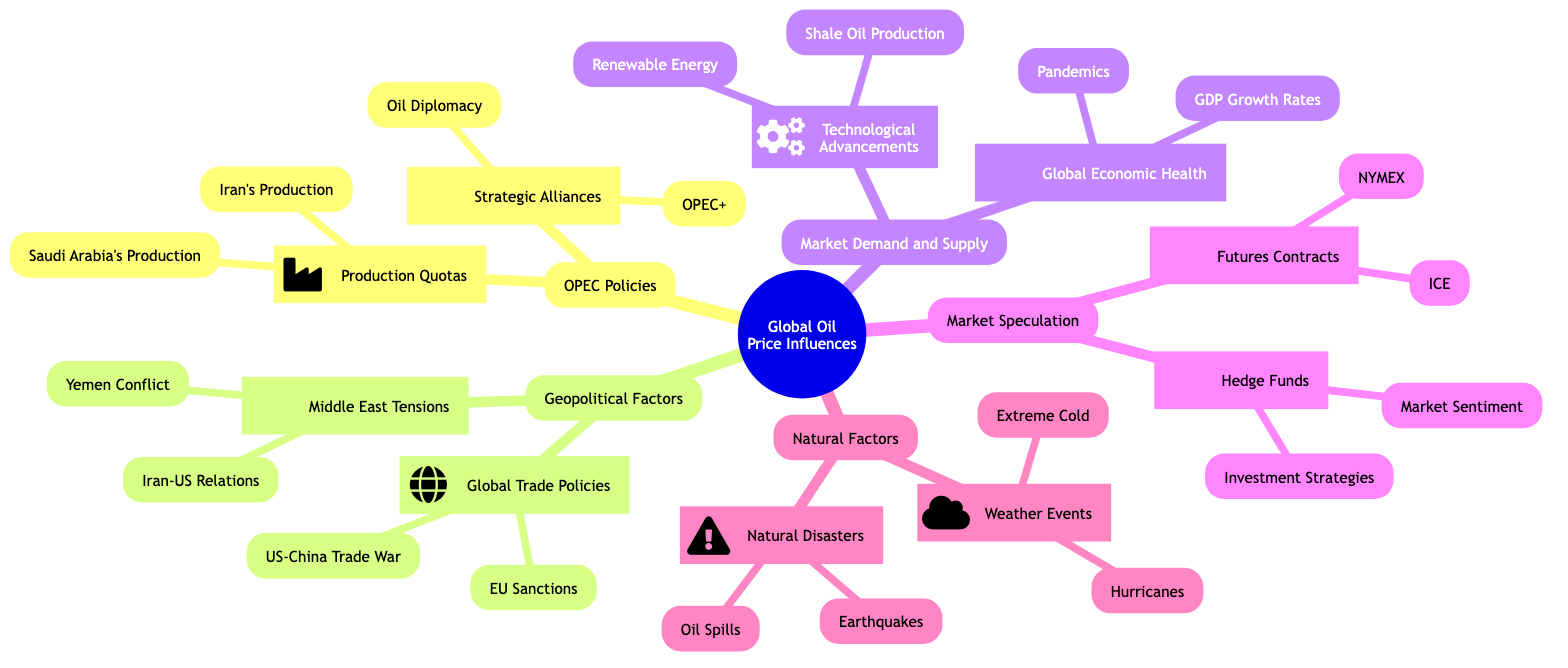What are the two main sections under OPEC Policies? The diagram shows two main sections under OPEC Policies: Production Quotas and Strategic Alliances.
Answer: Production Quotas, Strategic Alliances How many factors are listed under Geopolitical Factors? Under Geopolitical Factors, there are two factors: Middle East Tensions and Global Trade Policies, totaling two sections.
Answer: 2 Which country is specifically mentioned as having an influence on production adjustments? The diagram mentions Saudi Arabia's Production as having a leading role in production adjustments.
Answer: Saudi Arabia What is one impact of US-China Trade War? The diagram indicates that the US-China Trade War affects global demand and market stability.
Answer: Global demand and market stability What are the two types of natural factors listed? The types of natural factors listed are Weather Events and Natural Disasters.
Answer: Weather Events, Natural Disasters How does the production of shale oil affect global supply? The diagram notes that Shale Oil Production impacts global supply due to its production levels.
Answer: Impact on global supply What effect do hedge funds have on oil prices? Hedge funds influence oil prices through large capital movements and market sentiment.
Answer: Price volatility, trader perceptions Which exchange is associated with futures contracts? The NYMEX is specifically associated with futures contracts in the diagram.
Answer: NYMEX What are the two weather events mentioned that impact oil production? The diagram mentions Hurricanes and Extreme Cold as weather events that impact oil production.
Answer: Hurricanes, Extreme Cold How does oil diplomacy relate to strategic alliances? Oil Diplomacy involves bilateral agreements and negotiations, forming part of the Strategic Alliances section under OPEC Policies.
Answer: Bilateral agreements and negotiations 